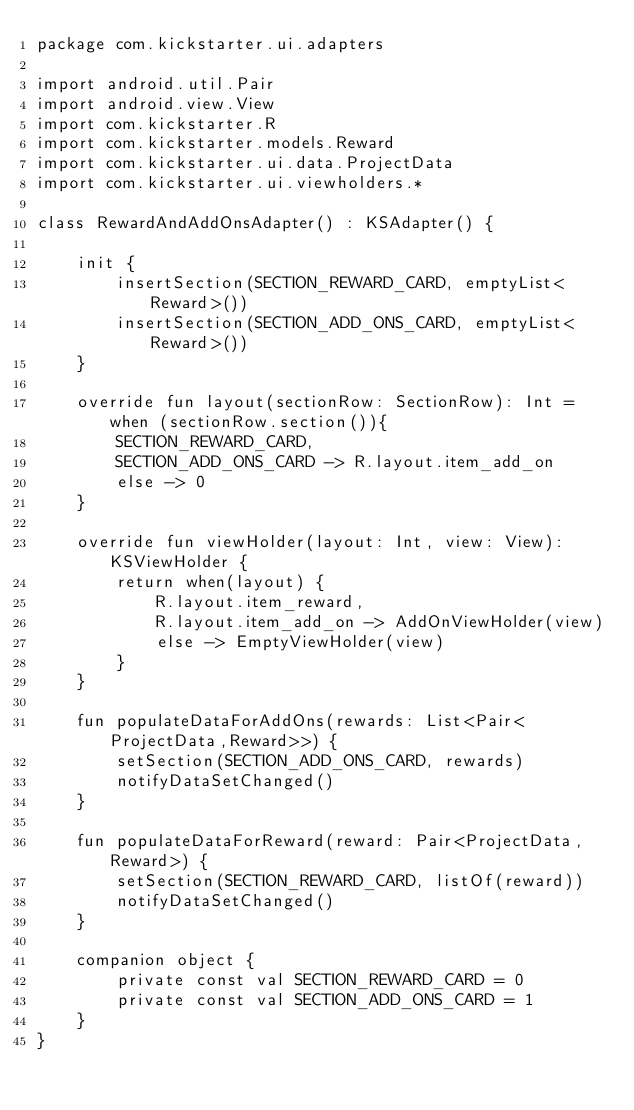<code> <loc_0><loc_0><loc_500><loc_500><_Kotlin_>package com.kickstarter.ui.adapters

import android.util.Pair
import android.view.View
import com.kickstarter.R
import com.kickstarter.models.Reward
import com.kickstarter.ui.data.ProjectData
import com.kickstarter.ui.viewholders.*

class RewardAndAddOnsAdapter() : KSAdapter() {

    init {
        insertSection(SECTION_REWARD_CARD, emptyList<Reward>())
        insertSection(SECTION_ADD_ONS_CARD, emptyList<Reward>())
    }

    override fun layout(sectionRow: SectionRow): Int = when (sectionRow.section()){
        SECTION_REWARD_CARD,
        SECTION_ADD_ONS_CARD -> R.layout.item_add_on
        else -> 0
    }

    override fun viewHolder(layout: Int, view: View): KSViewHolder {
        return when(layout) {
            R.layout.item_reward,
            R.layout.item_add_on -> AddOnViewHolder(view)
            else -> EmptyViewHolder(view)
        }
    }

    fun populateDataForAddOns(rewards: List<Pair<ProjectData,Reward>>) {
        setSection(SECTION_ADD_ONS_CARD, rewards)
        notifyDataSetChanged()
    }

    fun populateDataForReward(reward: Pair<ProjectData, Reward>) {
        setSection(SECTION_REWARD_CARD, listOf(reward))
        notifyDataSetChanged()
    }

    companion object {
        private const val SECTION_REWARD_CARD = 0
        private const val SECTION_ADD_ONS_CARD = 1
    }
}
</code> 